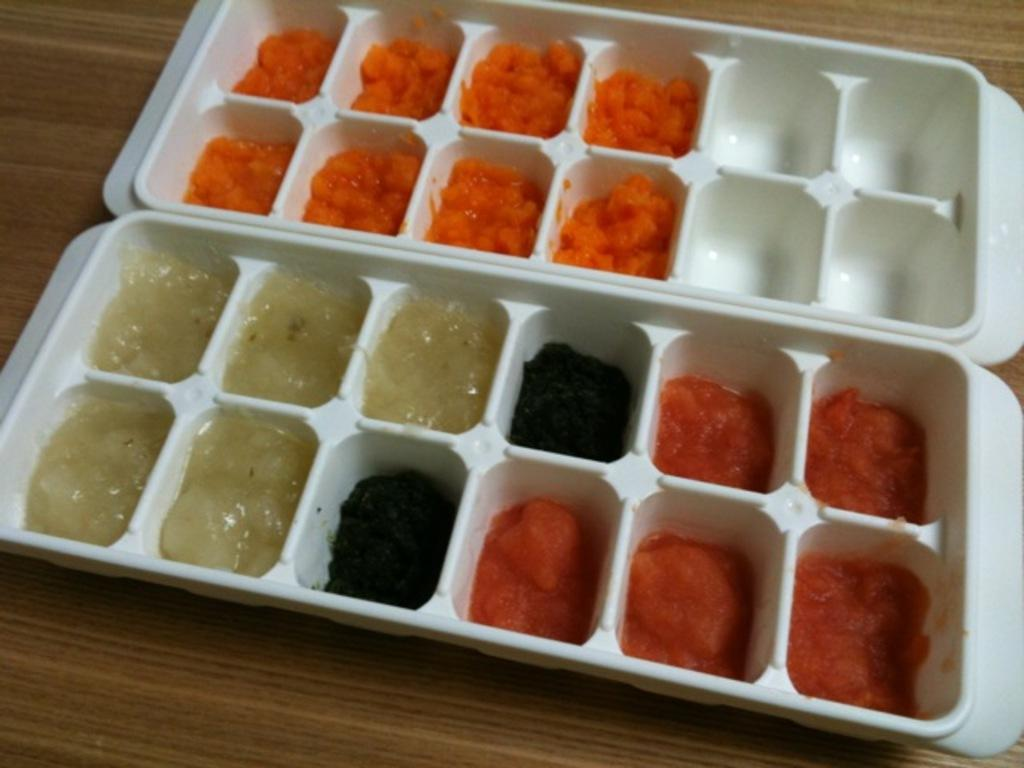What type of objects can be seen in the image? There are food items in the image. How are the food items arranged or organized? The food items are in trays. What is the surface beneath the trays made of? The trays are on a wooden surface. How much money is being exchanged for the food items in the image? There is no indication of money or any exchange in the image; it only shows food items in trays on a wooden surface. 